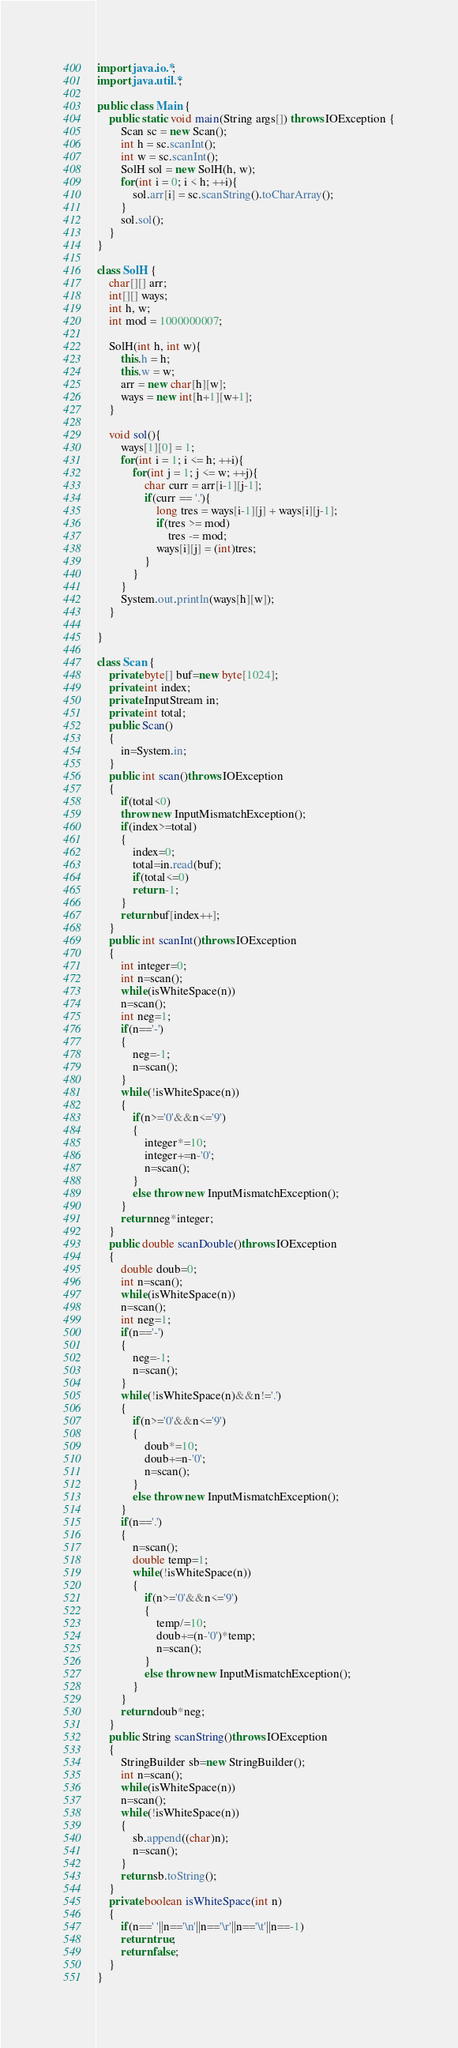<code> <loc_0><loc_0><loc_500><loc_500><_Java_>import java.io.*;
import java.util.*;

public class Main {
    public static void main(String args[]) throws IOException {
        Scan sc = new Scan();
        int h = sc.scanInt();
        int w = sc.scanInt();
        SolH sol = new SolH(h, w);
        for(int i = 0; i < h; ++i){
            sol.arr[i] = sc.scanString().toCharArray();
        }
        sol.sol();
    }
}

class SolH {
    char[][] arr;
    int[][] ways;
    int h, w;
    int mod = 1000000007;
    
    SolH(int h, int w){
        this.h = h;
        this.w = w;
        arr = new char[h][w];
        ways = new int[h+1][w+1];
    }
    
    void sol(){
        ways[1][0] = 1;
        for(int i = 1; i <= h; ++i){
            for(int j = 1; j <= w; ++j){
                char curr = arr[i-1][j-1];
                if(curr == '.'){
                    long tres = ways[i-1][j] + ways[i][j-1];
                    if(tres >= mod)
                        tres -= mod;
                    ways[i][j] = (int)tres;
                }
            }
        }
        System.out.println(ways[h][w]);
    }
    
}

class Scan {
    private byte[] buf=new byte[1024];
    private int index;
    private InputStream in;
    private int total;
    public Scan()
    {
        in=System.in;
    }
    public int scan()throws IOException
    {
        if(total<0)
        throw new InputMismatchException();
        if(index>=total)
        {
            index=0;
            total=in.read(buf);
            if(total<=0)
            return -1;
        }
        return buf[index++];
    }
    public int scanInt()throws IOException
    {
        int integer=0;
        int n=scan();
        while(isWhiteSpace(n))
        n=scan();
        int neg=1;
        if(n=='-')
        {
            neg=-1;
            n=scan();
        }
        while(!isWhiteSpace(n))
        {
            if(n>='0'&&n<='9')
            {
                integer*=10;
                integer+=n-'0';
                n=scan();
            }
            else throw new InputMismatchException();
        }
        return neg*integer;
    }
    public double scanDouble()throws IOException
    {
        double doub=0;
        int n=scan();
        while(isWhiteSpace(n))
        n=scan();
        int neg=1;
        if(n=='-')
        {
            neg=-1;
            n=scan();
        }
        while(!isWhiteSpace(n)&&n!='.')
        {
            if(n>='0'&&n<='9')
            {
                doub*=10;
                doub+=n-'0';
                n=scan();
            }
            else throw new InputMismatchException();
        }
        if(n=='.')
        {
            n=scan();
            double temp=1;
            while(!isWhiteSpace(n))
            {
                if(n>='0'&&n<='9')
                {
                    temp/=10;
                    doub+=(n-'0')*temp;
                    n=scan();
                }
                else throw new InputMismatchException();
            }
        }
        return doub*neg;
    }
    public String scanString()throws IOException
    {
        StringBuilder sb=new StringBuilder();
        int n=scan();
        while(isWhiteSpace(n))
        n=scan();
        while(!isWhiteSpace(n))
        {
            sb.append((char)n);
            n=scan();
        }
        return sb.toString();
    }
    private boolean isWhiteSpace(int n)
    {
        if(n==' '||n=='\n'||n=='\r'||n=='\t'||n==-1)
        return true;
        return false;
    }
}</code> 